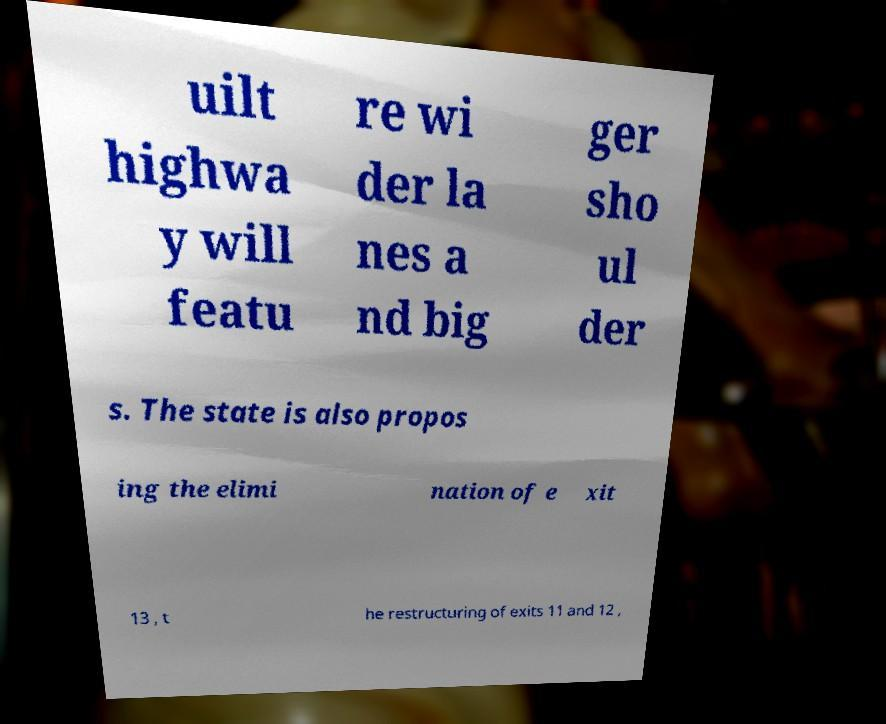Could you assist in decoding the text presented in this image and type it out clearly? uilt highwa y will featu re wi der la nes a nd big ger sho ul der s. The state is also propos ing the elimi nation of e xit 13 , t he restructuring of exits 11 and 12 , 